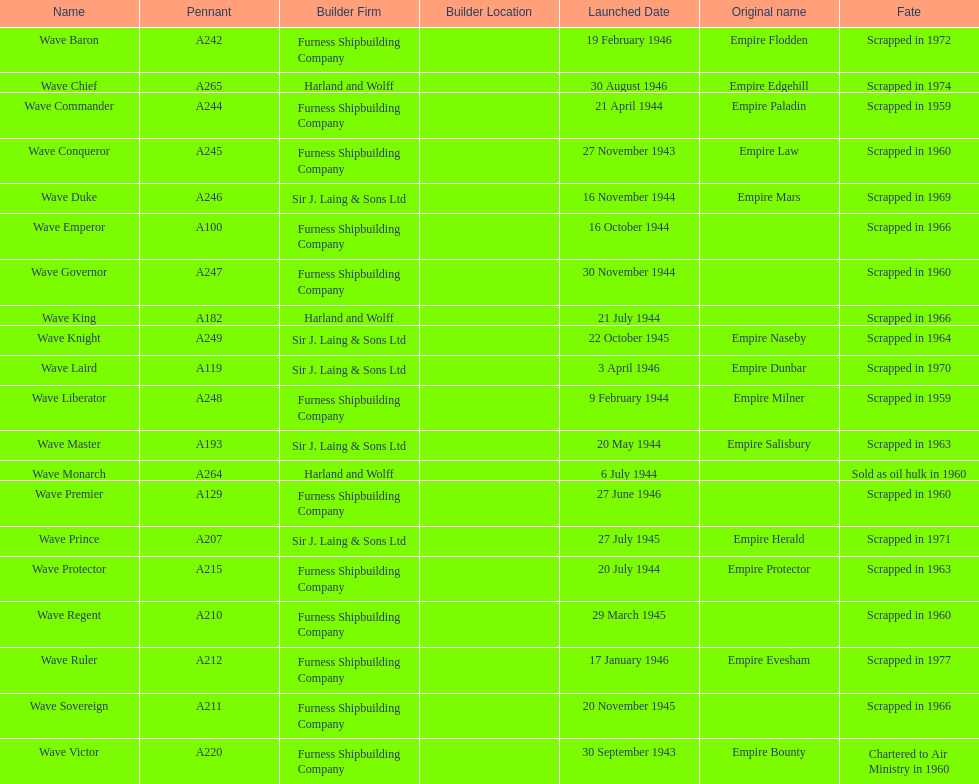Parse the table in full. {'header': ['Name', 'Pennant', 'Builder Firm', 'Builder Location', 'Launched Date', 'Original name', 'Fate'], 'rows': [['Wave Baron', 'A242', 'Furness Shipbuilding Company', '', '19 February 1946', 'Empire Flodden', 'Scrapped in 1972'], ['Wave Chief', 'A265', 'Harland and Wolff', '', '30 August 1946', 'Empire Edgehill', 'Scrapped in 1974'], ['Wave Commander', 'A244', 'Furness Shipbuilding Company', '', '21 April 1944', 'Empire Paladin', 'Scrapped in 1959'], ['Wave Conqueror', 'A245', 'Furness Shipbuilding Company', '', '27 November 1943', 'Empire Law', 'Scrapped in 1960'], ['Wave Duke', 'A246', 'Sir J. Laing & Sons Ltd', '', '16 November 1944', 'Empire Mars', 'Scrapped in 1969'], ['Wave Emperor', 'A100', 'Furness Shipbuilding Company', '', '16 October 1944', '', 'Scrapped in 1966'], ['Wave Governor', 'A247', 'Furness Shipbuilding Company', '', '30 November 1944', '', 'Scrapped in 1960'], ['Wave King', 'A182', 'Harland and Wolff', '', '21 July 1944', '', 'Scrapped in 1966'], ['Wave Knight', 'A249', 'Sir J. Laing & Sons Ltd', '', '22 October 1945', 'Empire Naseby', 'Scrapped in 1964'], ['Wave Laird', 'A119', 'Sir J. Laing & Sons Ltd', '', '3 April 1946', 'Empire Dunbar', 'Scrapped in 1970'], ['Wave Liberator', 'A248', 'Furness Shipbuilding Company', '', '9 February 1944', 'Empire Milner', 'Scrapped in 1959'], ['Wave Master', 'A193', 'Sir J. Laing & Sons Ltd', '', '20 May 1944', 'Empire Salisbury', 'Scrapped in 1963'], ['Wave Monarch', 'A264', 'Harland and Wolff', '', '6 July 1944', '', 'Sold as oil hulk in 1960'], ['Wave Premier', 'A129', 'Furness Shipbuilding Company', '', '27 June 1946', '', 'Scrapped in 1960'], ['Wave Prince', 'A207', 'Sir J. Laing & Sons Ltd', '', '27 July 1945', 'Empire Herald', 'Scrapped in 1971'], ['Wave Protector', 'A215', 'Furness Shipbuilding Company', '', '20 July 1944', 'Empire Protector', 'Scrapped in 1963'], ['Wave Regent', 'A210', 'Furness Shipbuilding Company', '', '29 March 1945', '', 'Scrapped in 1960'], ['Wave Ruler', 'A212', 'Furness Shipbuilding Company', '', '17 January 1946', 'Empire Evesham', 'Scrapped in 1977'], ['Wave Sovereign', 'A211', 'Furness Shipbuilding Company', '', '20 November 1945', '', 'Scrapped in 1966'], ['Wave Victor', 'A220', 'Furness Shipbuilding Company', '', '30 September 1943', 'Empire Bounty', 'Chartered to Air Ministry in 1960']]} What date was the first ship launched? 30 September 1943. 